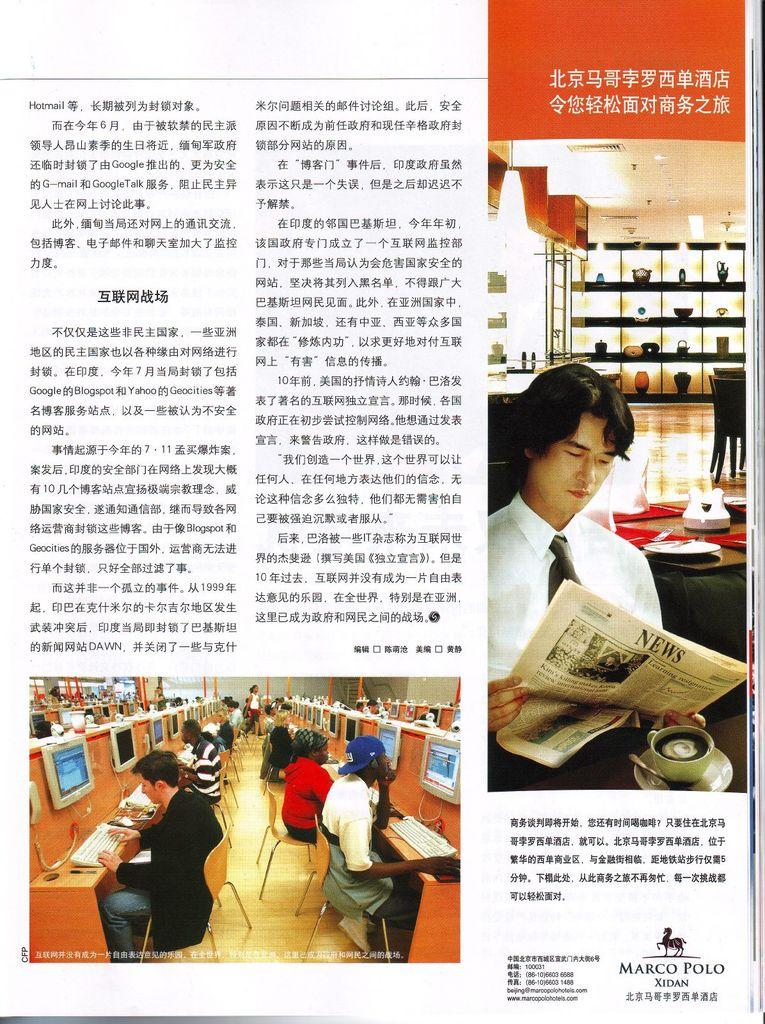Provide a one-sentence caption for the provided image. Marco Polo Xidan is a company that produces Chinese magazine news articles. 